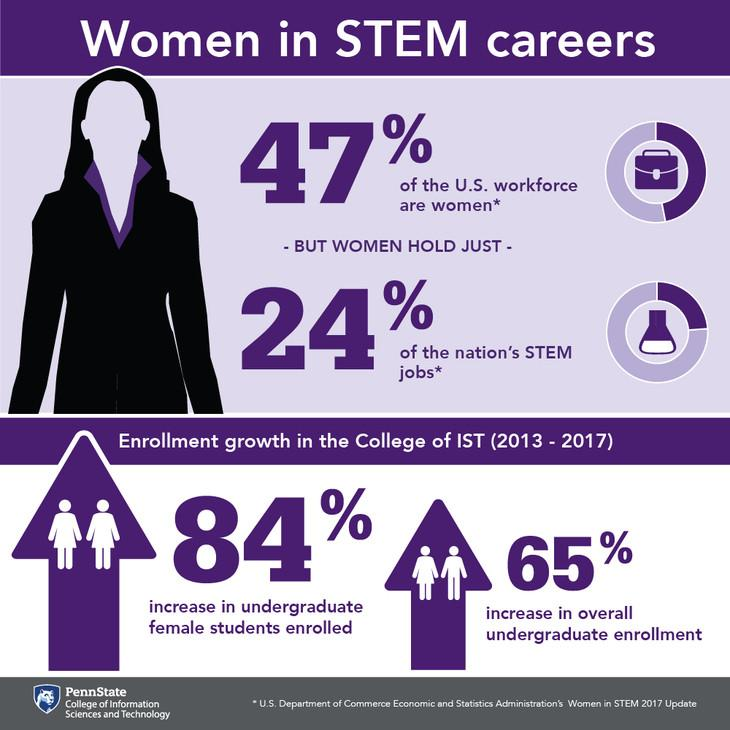Highlight a few significant elements in this photo. A disturbing percentage of STEM jobs in the nation are not held by women, with 76.. 53% of the US workforce are not women. 